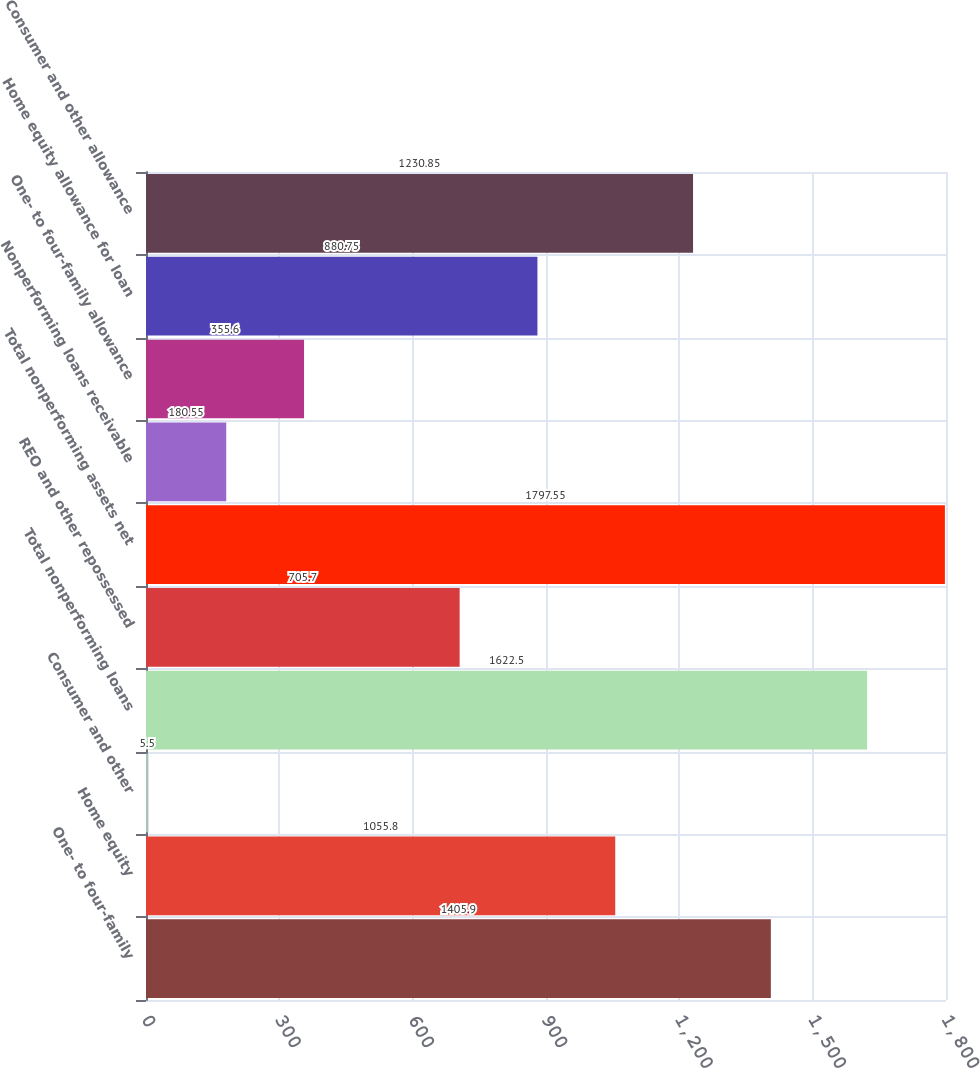Convert chart to OTSL. <chart><loc_0><loc_0><loc_500><loc_500><bar_chart><fcel>One- to four-family<fcel>Home equity<fcel>Consumer and other<fcel>Total nonperforming loans<fcel>REO and other repossessed<fcel>Total nonperforming assets net<fcel>Nonperforming loans receivable<fcel>One- to four-family allowance<fcel>Home equity allowance for loan<fcel>Consumer and other allowance<nl><fcel>1405.9<fcel>1055.8<fcel>5.5<fcel>1622.5<fcel>705.7<fcel>1797.55<fcel>180.55<fcel>355.6<fcel>880.75<fcel>1230.85<nl></chart> 